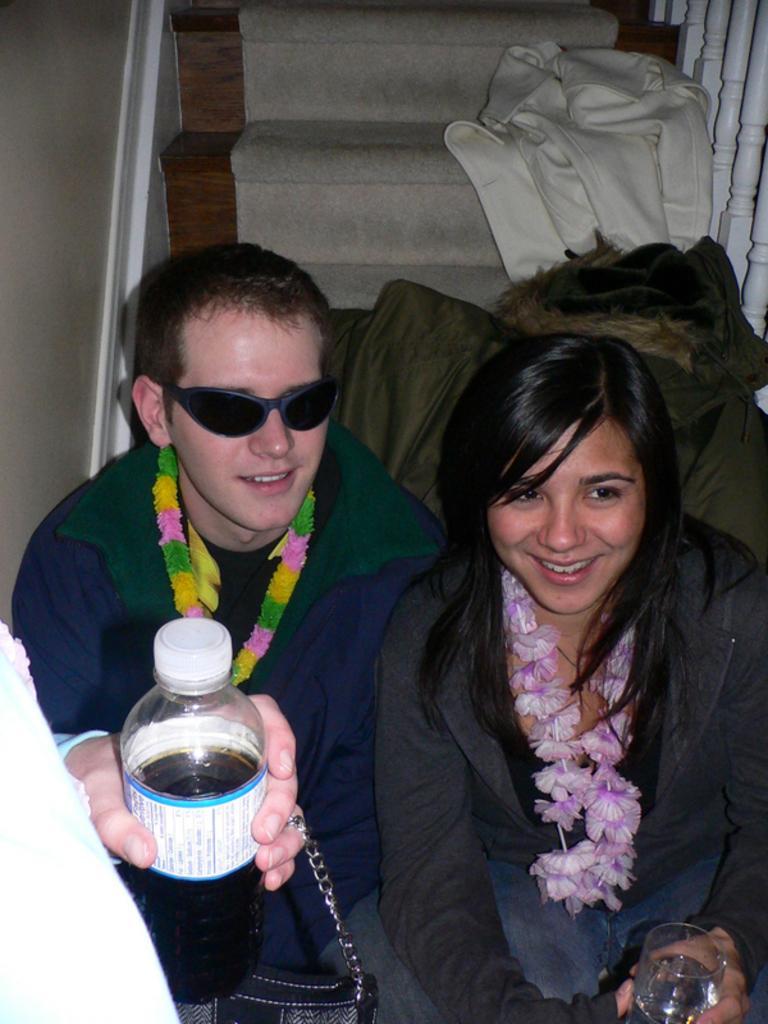In one or two sentences, can you explain what this image depicts? This man and this women are sitting on steps and smiling. On this steps there is a carpet and jacket. A person is holding a bottle. This woman and this man wore garland and holding a glass of water. 